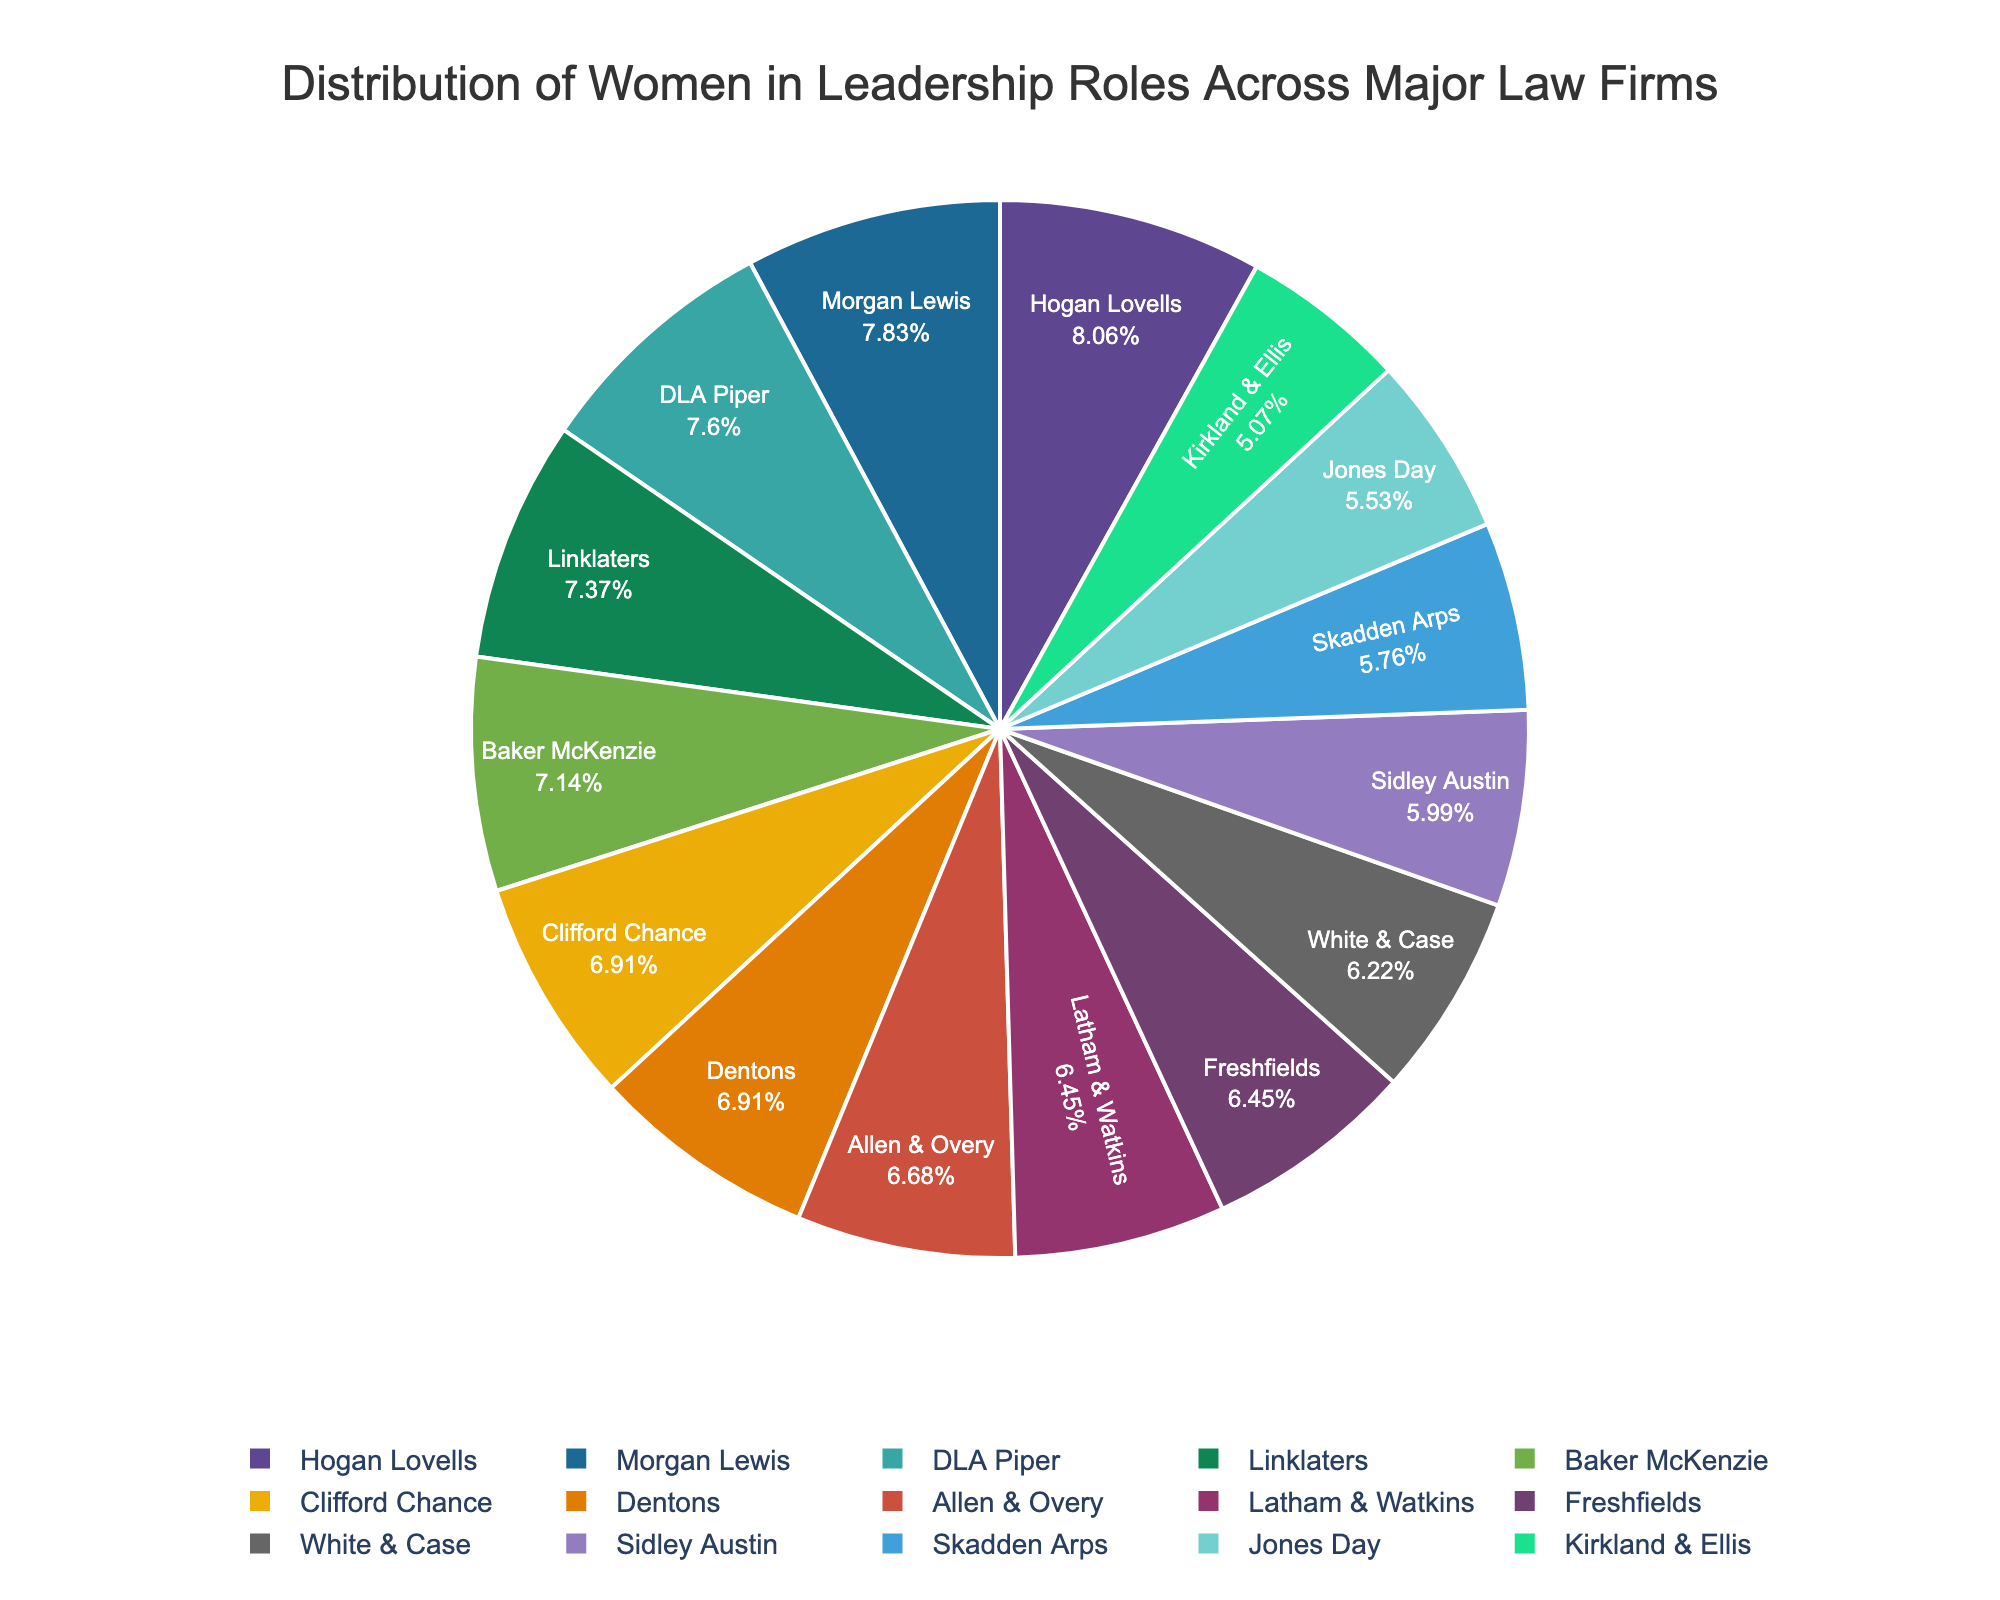What percentage of leadership roles is held by women at Hogan Lovells? To find the percentage of leadership roles held by women at Hogan Lovells, locate "Hogan Lovells" on the pie chart and read the corresponding percentage value.
Answer: 35% Which firm has the lowest percentage of women in leadership roles? To determine which firm has the lowest percentage of women in leadership roles, look for the segment in the pie chart with the smallest slice and read the corresponding firm name.
Answer: Kirkland & Ellis What is the combined percentage of women in leadership roles at Skadden Arps and Jones Day? First find the percentage of women in leadership roles at Skadden Arps (25%) and Jones Day (24%). Add these two percentages together: 25% + 24% = 49%.
Answer: 49% Are there any firms with an equal percentage of women in leadership roles? If so, which ones? Examine the pie chart to identify firms sharing identical percentage values. "Baker McKenzie" and "Dentons" each have 30%, and "Clifford Chance" and "Dentons" each have 30%.
Answer: Baker McKenzie and Dentons; Clifford Chance and Dentons How does Morgan Lewis compare to Latham & Watkins in terms of the percentage of women in leadership roles? Find the segments representing Morgan Lewis (34%) and Latham & Watkins (28%), and compare their sizes to determine which one has a higher value.
Answer: Morgan Lewis has a higher percentage What is the average percentage of women in leadership roles across all the firms listed? Sum the percentages of all firms (28 + 25 + 31 + 33 + 22 + 27 + 30 + 29 + 32 + 35 + 26 + 34 + 30 + 24 + 28 = 404) and divide by the number of firms (15). Average = 404 / 15 = 26.93%.
Answer: 26.93% Which law firms have a percentage of women in leadership roles above 30%? Identify the firms with slices in the pie chart that indicate a percentage above 30%. These firms include Baker McKenzie, DLA Piper, Linklaters, Hogan Lovells, Morgan Lewis, and Sidley Austin.
Answer: Baker McKenzie, DLA Piper, Linklaters, Hogan Lovells, Morgan Lewis Which firm holds a higher percentage of women in leadership roles: Allen & Overy or Freshfields? Compare the percentages for Allen & Overy (29%) and Freshfields (28%) as shown in the pie chart.
Answer: Allen & Overy How much greater is the percentage of women in leadership roles at Morgan Lewis compared to White & Case? Subtract the percentage of women in leadership roles at White & Case (27%) from Morgan Lewis (34%). The difference is 34% - 27% = 7%.
Answer: 7% 